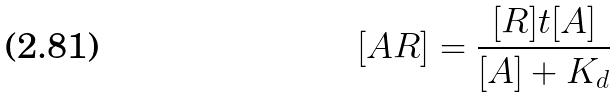<formula> <loc_0><loc_0><loc_500><loc_500>[ A R ] = \frac { [ R ] t [ A ] } { [ A ] + K _ { d } }</formula> 